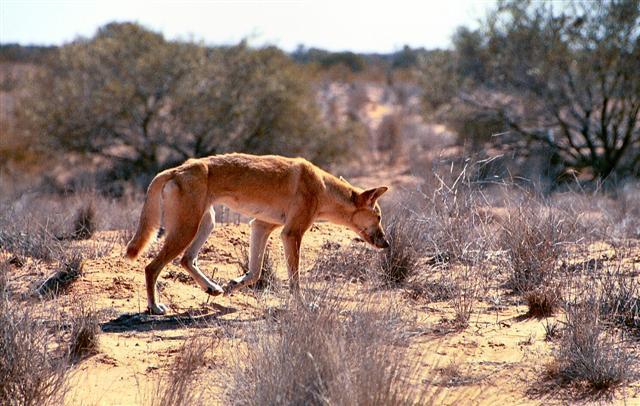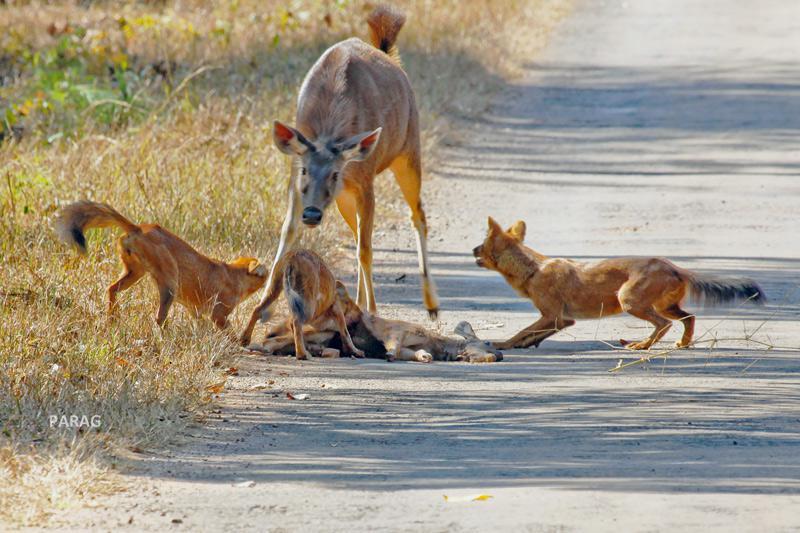The first image is the image on the left, the second image is the image on the right. Evaluate the accuracy of this statement regarding the images: "One of the photos shows a wild dog biting another animal.". Is it true? Answer yes or no. Yes. 